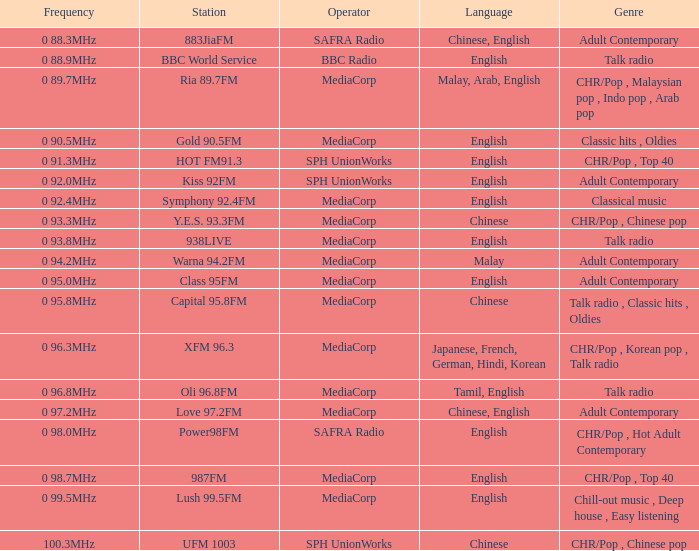What is the category of the bbc world service? Talk radio. 